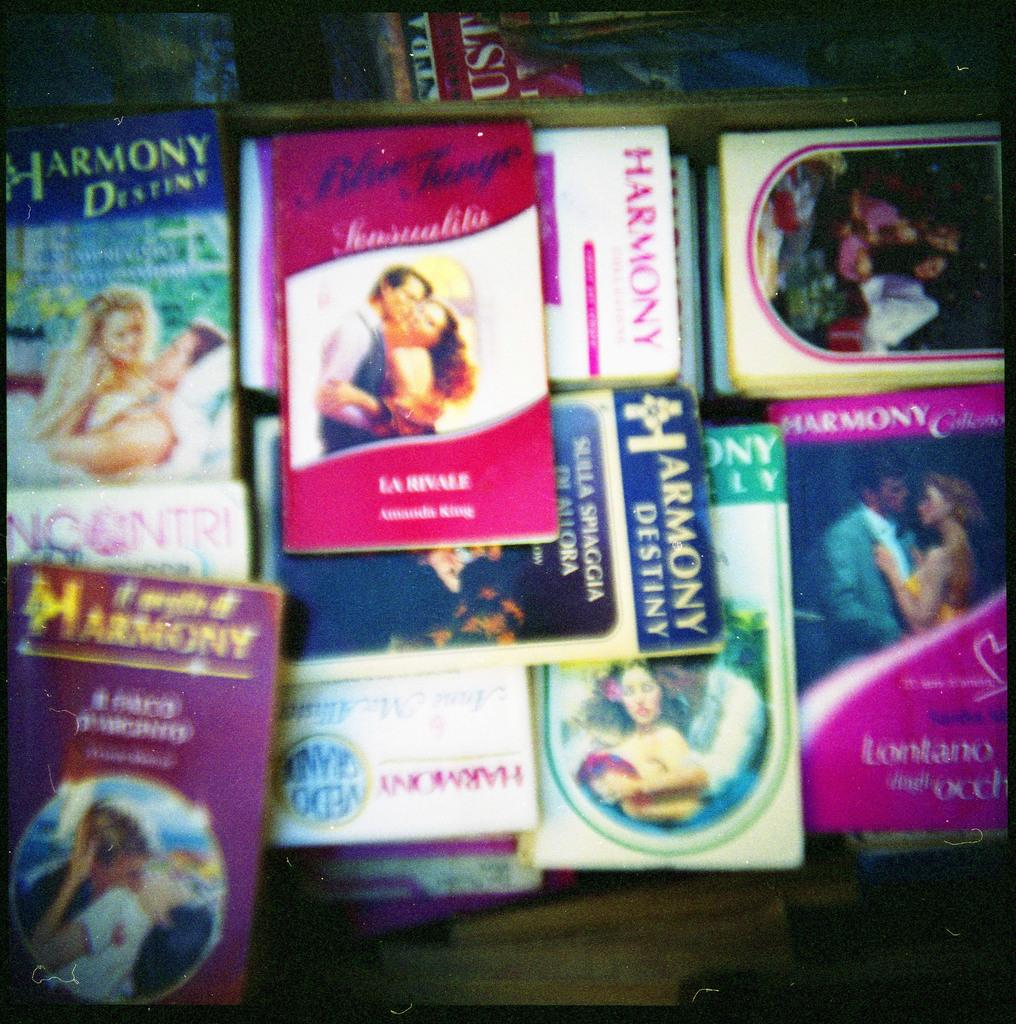<image>
Give a short and clear explanation of the subsequent image. A pile of books published by Harmony publishers. 